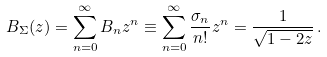Convert formula to latex. <formula><loc_0><loc_0><loc_500><loc_500>B _ { \Sigma } ( z ) = \sum _ { n = 0 } ^ { \infty } B _ { n } z ^ { n } \equiv \sum _ { n = 0 } ^ { \infty } \frac { \sigma _ { n } } { n ! } z ^ { n } = \frac { 1 } { \sqrt { 1 - 2 z } } \, .</formula> 